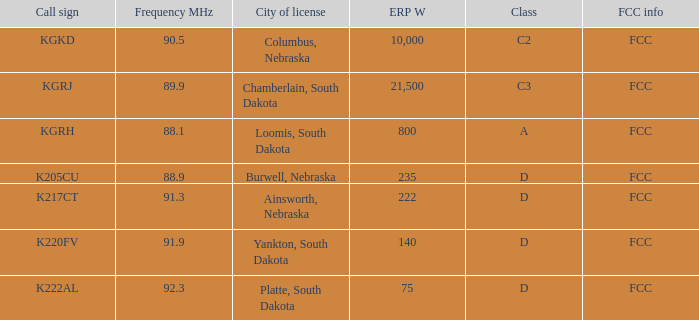What is the call sign with a 222 erp w? K217CT. 